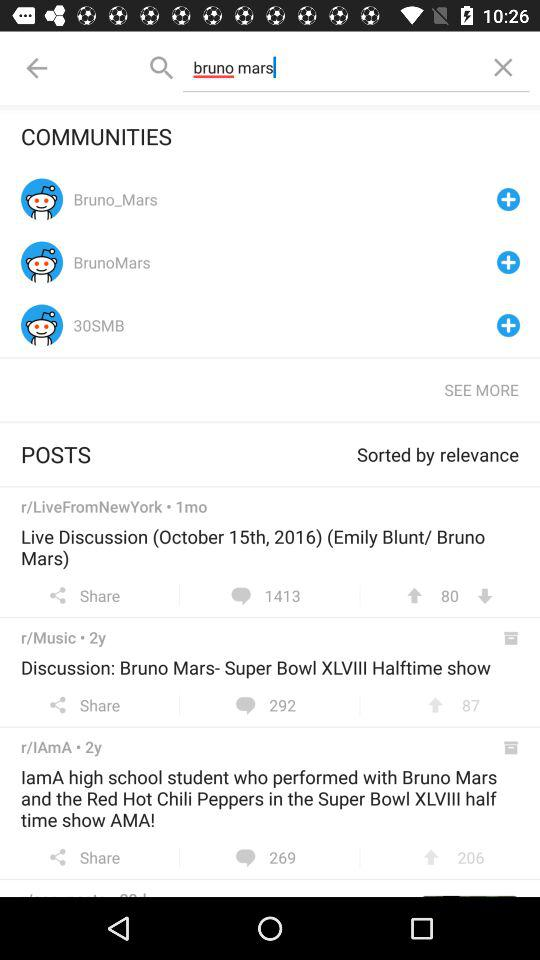How many downloads on live discussion? There are 80 downloads. 